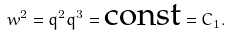<formula> <loc_0><loc_0><loc_500><loc_500>w ^ { 2 } = q ^ { 2 } q ^ { 3 } = \text {const} = C _ { 1 } .</formula> 